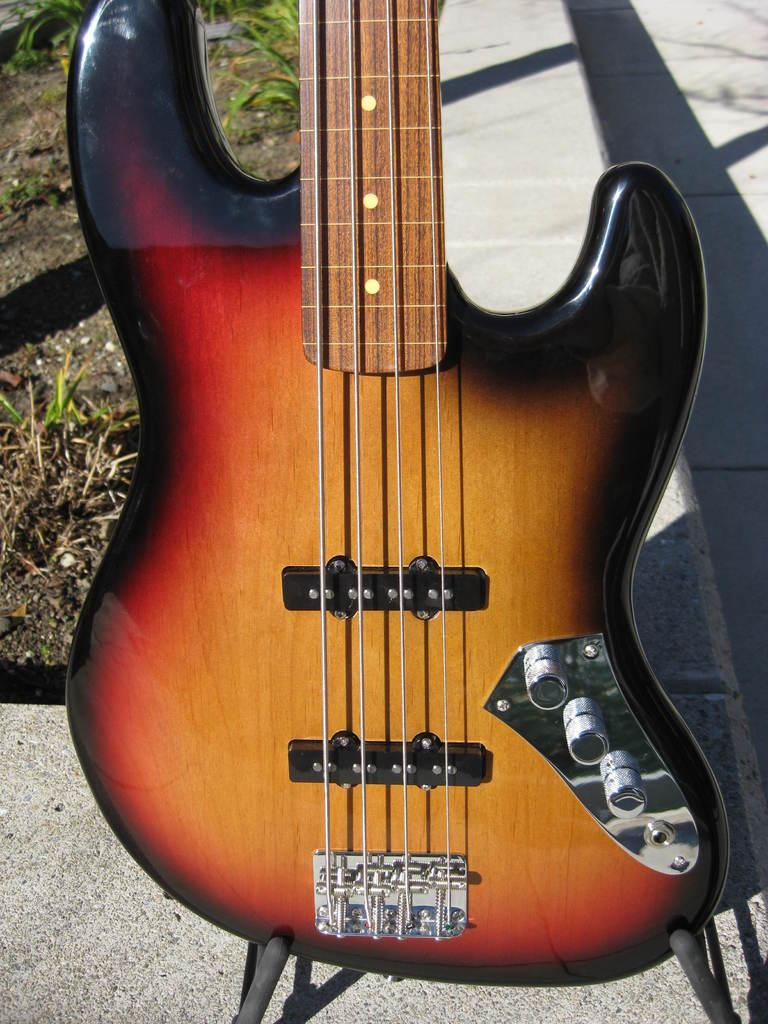What is the main subject of the image? The main subject of the image is a guitar. What color is the guitar? The guitar is brown in color. How many strings does the guitar have? The guitar has four strings. What can be seen in the background of the image? There is a shadow of the guitar in the background. What type of environment is visible to the left of the guitar? Soil and grass are present to the left of the guitar. What is the reaction of the secretary to the pig in the image? There is no secretary or pig present in the image; it features a brown guitar with four strings and a background shadow. 